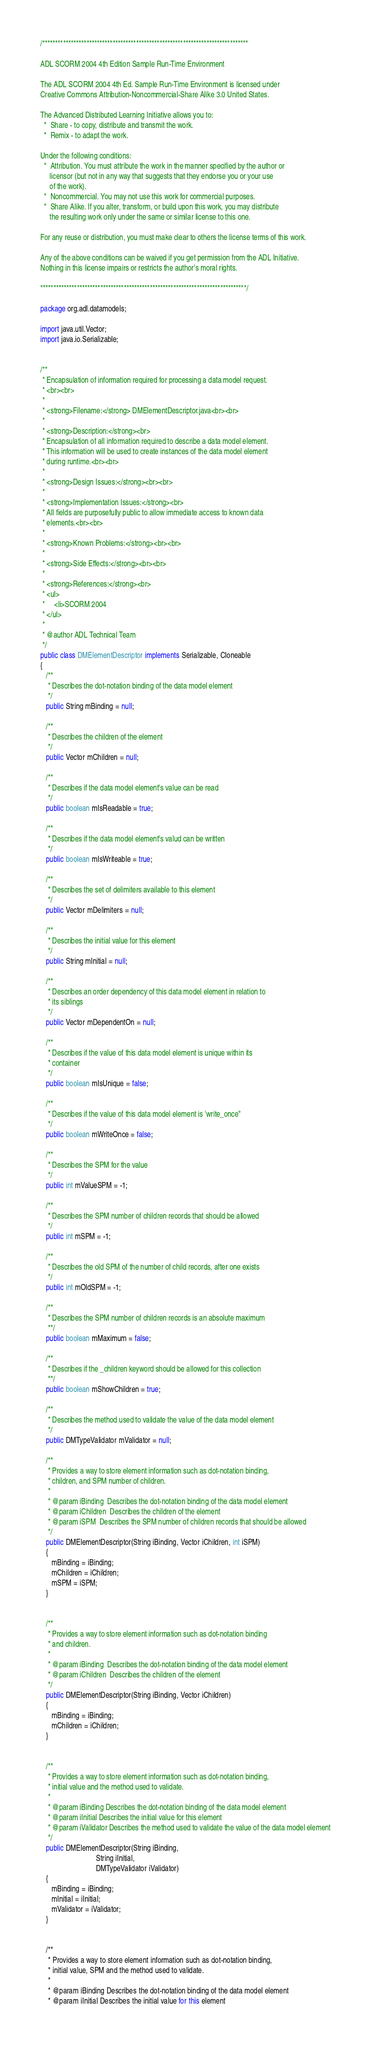Convert code to text. <code><loc_0><loc_0><loc_500><loc_500><_Java_>/*******************************************************************************

ADL SCORM 2004 4th Edition Sample Run-Time Environment

The ADL SCORM 2004 4th Ed. Sample Run-Time Environment is licensed under
Creative Commons Attribution-Noncommercial-Share Alike 3.0 United States.

The Advanced Distributed Learning Initiative allows you to:
  *  Share - to copy, distribute and transmit the work.
  *  Remix - to adapt the work. 

Under the following conditions:
  *  Attribution. You must attribute the work in the manner specified by the author or
     licensor (but not in any way that suggests that they endorse you or your use
     of the work).
  *  Noncommercial. You may not use this work for commercial purposes. 
  *  Share Alike. If you alter, transform, or build upon this work, you may distribute
     the resulting work only under the same or similar license to this one. 

For any reuse or distribution, you must make clear to others the license terms of this work. 

Any of the above conditions can be waived if you get permission from the ADL Initiative. 
Nothing in this license impairs or restricts the author's moral rights.

*******************************************************************************/

package org.adl.datamodels;

import java.util.Vector;
import java.io.Serializable;


/**
 * Encapsulation of information required for processing a data model request.
 * <br><br>
 * 
 * <strong>Filename:</strong> DMElementDescriptor.java<br><br>
 * 
 * <strong>Description:</strong><br>
 * Encapsulation of all information required to describe a data model element.
 * This information will be used to create instances of the data model element
 * during runtime.<br><br>
 * 
 * <strong>Design Issues:</strong><br><br>
 * 
 * <strong>Implementation Issues:</strong><br>
 * All fields are purposefully public to allow immediate access to known data
 * elements.<br><br>
 * 
 * <strong>Known Problems:</strong><br><br>
 * 
 * <strong>Side Effects:</strong><br><br>
 * 
 * <strong>References:</strong><br>
 * <ul>
 *     <li>SCORM 2004
 * </ul>
 * 
 * @author ADL Technical Team
 */ 
public class DMElementDescriptor implements Serializable, Cloneable  
{
   /**
    * Describes the dot-notation binding of the data model element
    */
   public String mBinding = null;

   /**
    * Describes the children of the element
    */
   public Vector mChildren = null;

   /**
    * Describes if the data model element's value can be read
    */
   public boolean mIsReadable = true;

   /**
    * Describes if the data model element's valud can be written
    */
   public boolean mIsWriteable = true;

   /**
    * Describes the set of delimiters available to this element
    */
   public Vector mDelimiters = null;

   /**
    * Describes the initial value for this element
    */
   public String mInitial = null;

   /**
    * Describes an order dependency of this data model element in relation to 
    * its siblings
    */
   public Vector mDependentOn = null;

   /** 
    * Describes if the value of this data model element is unique within its
    * container
    */
   public boolean mIsUnique = false;

   /** 
    * Describes if the value of this data model element is 'write_once"
    */
   public boolean mWriteOnce = false;

   /**
    * Describes the SPM for the value
    */
   public int mValueSPM = -1;

   /**
    * Describes the SPM number of children records that should be allowed
    */
   public int mSPM = -1;

   /**
    * Describes the old SPM of the number of child records, after one exists
    */
   public int mOldSPM = -1;

   /**
    * Describes the SPM number of children records is an absolute maximum 
    **/
   public boolean mMaximum = false;

   /**
    * Describes if the _children keyword should be allowed for this collection 
    **/
   public boolean mShowChildren = true;

   /**
    * Describes the method used to validate the value of the data model element
    */
   public DMTypeValidator mValidator = null;

   /**
    * Provides a way to store element information such as dot-notation binding, 
    * children, and SPM number of children.
    * 
    * @param iBinding  Describes the dot-notation binding of the data model element
    * @param iChildren  Describes the children of the element
    * @param iSPM  Describes the SPM number of children records that should be allowed
    */
   public DMElementDescriptor(String iBinding, Vector iChildren, int iSPM)
   {
      mBinding = iBinding;
      mChildren = iChildren;
      mSPM = iSPM;
   }


   /**
    * Provides a way to store element information such as dot-notation binding 
    * and children.
    * 
    * @param iBinding  Describes the dot-notation binding of the data model element
    * @param iChildren  Describes the children of the element
    */
   public DMElementDescriptor(String iBinding, Vector iChildren)
   {
      mBinding = iBinding;
      mChildren = iChildren;
   }


   /**
    * Provides a way to store element information such as dot-notation binding, 
    * initial value and the method used to validate.
    * 
    * @param iBinding Describes the dot-notation binding of the data model element
    * @param iInitial Describes the initial value for this element
    * @param iValidator Describes the method used to validate the value of the data model element
    */
   public DMElementDescriptor(String iBinding,
                              String iInitial,
                              DMTypeValidator iValidator)
   {
      mBinding = iBinding;
      mInitial = iInitial;
      mValidator = iValidator;
   }


   /**
    * Provides a way to store element information such as dot-notation binding, 
    * initial value, SPM and the method used to validate.
    * 
    * @param iBinding Describes the dot-notation binding of the data model element
    * @param iInitial Describes the initial value for this element</code> 